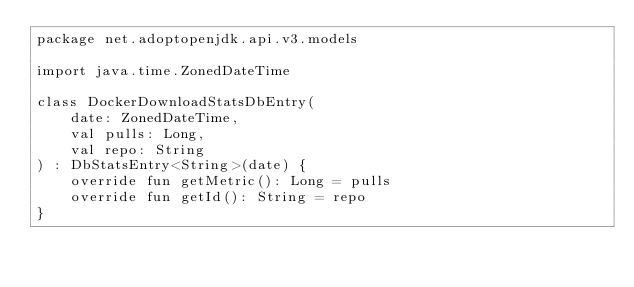Convert code to text. <code><loc_0><loc_0><loc_500><loc_500><_Kotlin_>package net.adoptopenjdk.api.v3.models

import java.time.ZonedDateTime

class DockerDownloadStatsDbEntry(
    date: ZonedDateTime,
    val pulls: Long,
    val repo: String
) : DbStatsEntry<String>(date) {
    override fun getMetric(): Long = pulls
    override fun getId(): String = repo
}
</code> 